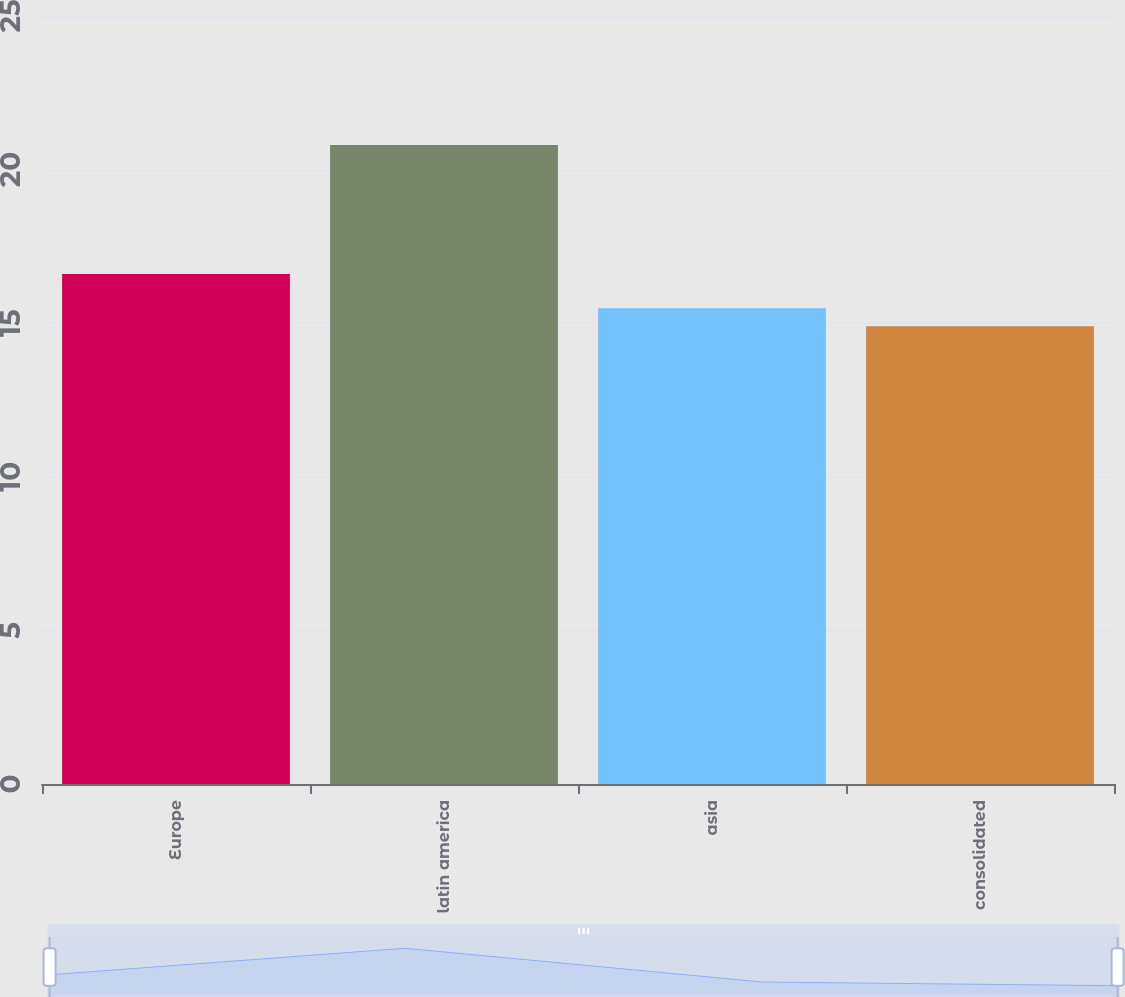Convert chart to OTSL. <chart><loc_0><loc_0><loc_500><loc_500><bar_chart><fcel>Europe<fcel>latin america<fcel>asia<fcel>consolidated<nl><fcel>16.6<fcel>20.8<fcel>15.49<fcel>14.9<nl></chart> 